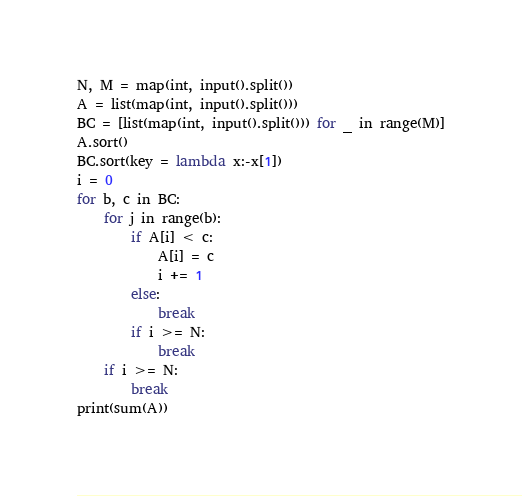<code> <loc_0><loc_0><loc_500><loc_500><_Python_>N, M = map(int, input().split())
A = list(map(int, input().split()))
BC = [list(map(int, input().split())) for _ in range(M)]
A.sort()
BC.sort(key = lambda x:-x[1])
i = 0
for b, c in BC:
    for j in range(b):
        if A[i] < c:
            A[i] = c
            i += 1
        else:
            break
        if i >= N:
            break
    if i >= N:
        break
print(sum(A))</code> 